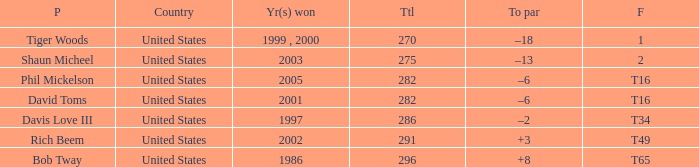What is Davis Love III's total? 286.0. 